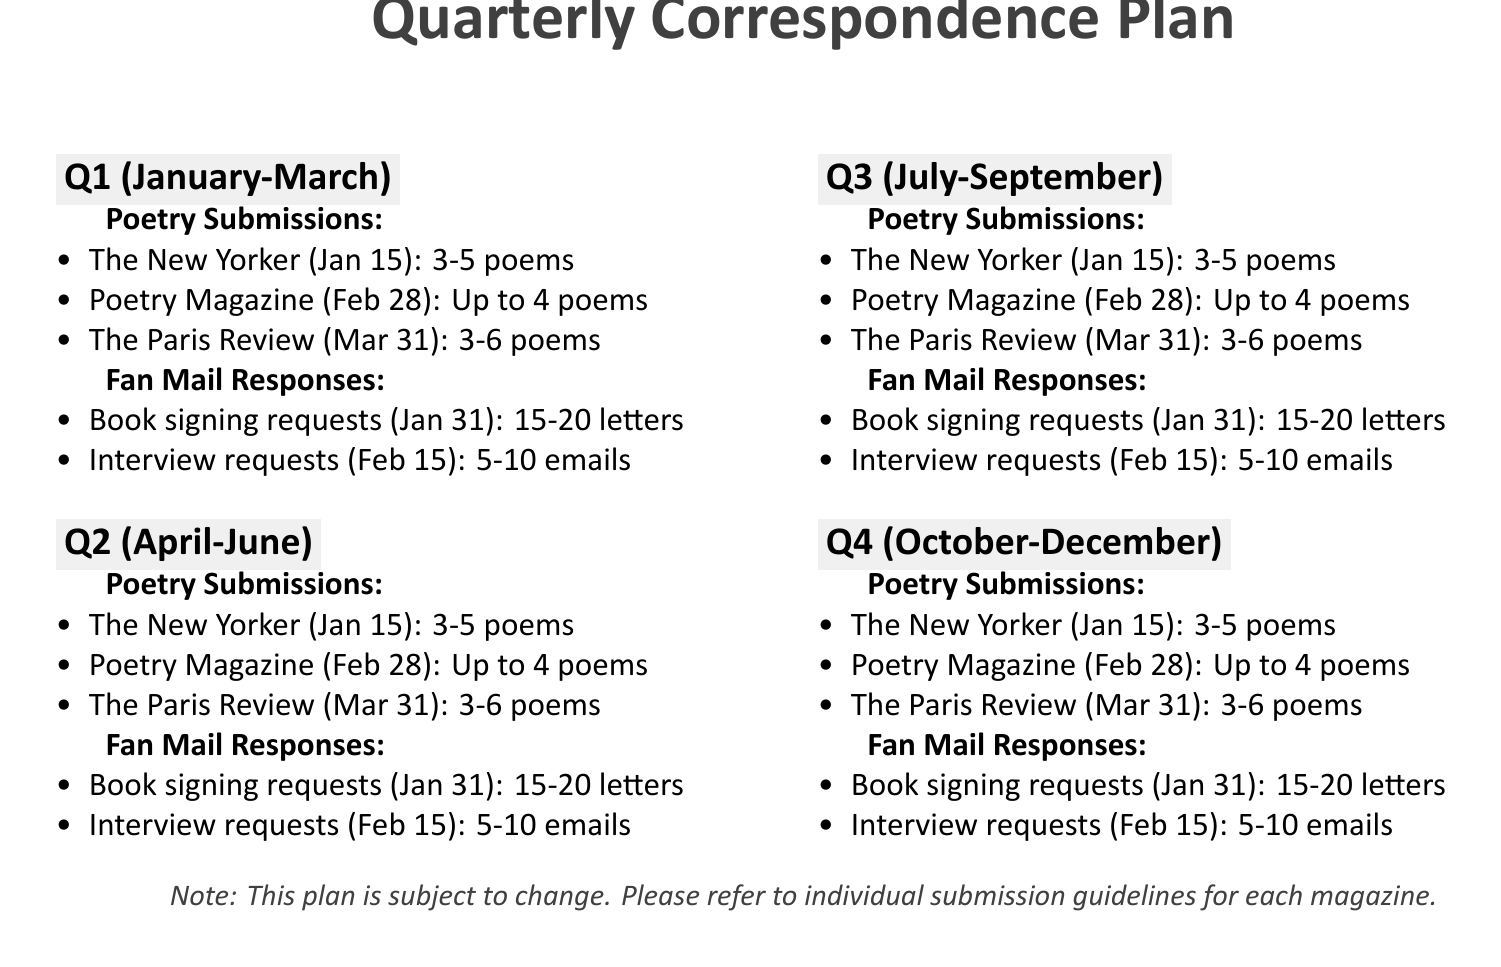What is the deadline for The New Yorker submissions? The deadline for The New Yorker is specified clearly in the document as January 15.
Answer: January 15 How many poems can be submitted to Poetry Magazine? The document states that up to 4 poems can be submitted to Poetry Magazine.
Answer: Up to 4 poems What is the estimated volume of school visit requests? The estimated volume for school visit requests as provided in the document is 20-30 emails.
Answer: 20-30 emails Which magazine has the earliest submission deadline in Q2? The earliest submission deadline in Q2 is for Ploughshares, which is due on April 15.
Answer: Ploughshares What method is used to respond to general fan letters in Q3? The document notes that general fan letters will be responded to with pre-signed postcards with a personal note.
Answer: Pre-signed postcards with personal note What is the response method for holiday greetings in Q4? According to the plan, holiday greetings will be responded to with personalized holiday cards with a poem excerpt.
Answer: Personalized holiday cards with poem excerpt How many poems can be submitted to Rattle? The document mentions that 4-5 poems can be submitted to Rattle.
Answer: 4-5 poems What category of fan mail has a deadline of March 31? The category that has a submission deadline of March 31 is related to The Paris Review for poetry submissions.
Answer: The Paris Review What is noted as the submission type for The Southern Review? The submission type for The Southern Review is specified to be up to 5 poems.
Answer: Up to 5 poems 